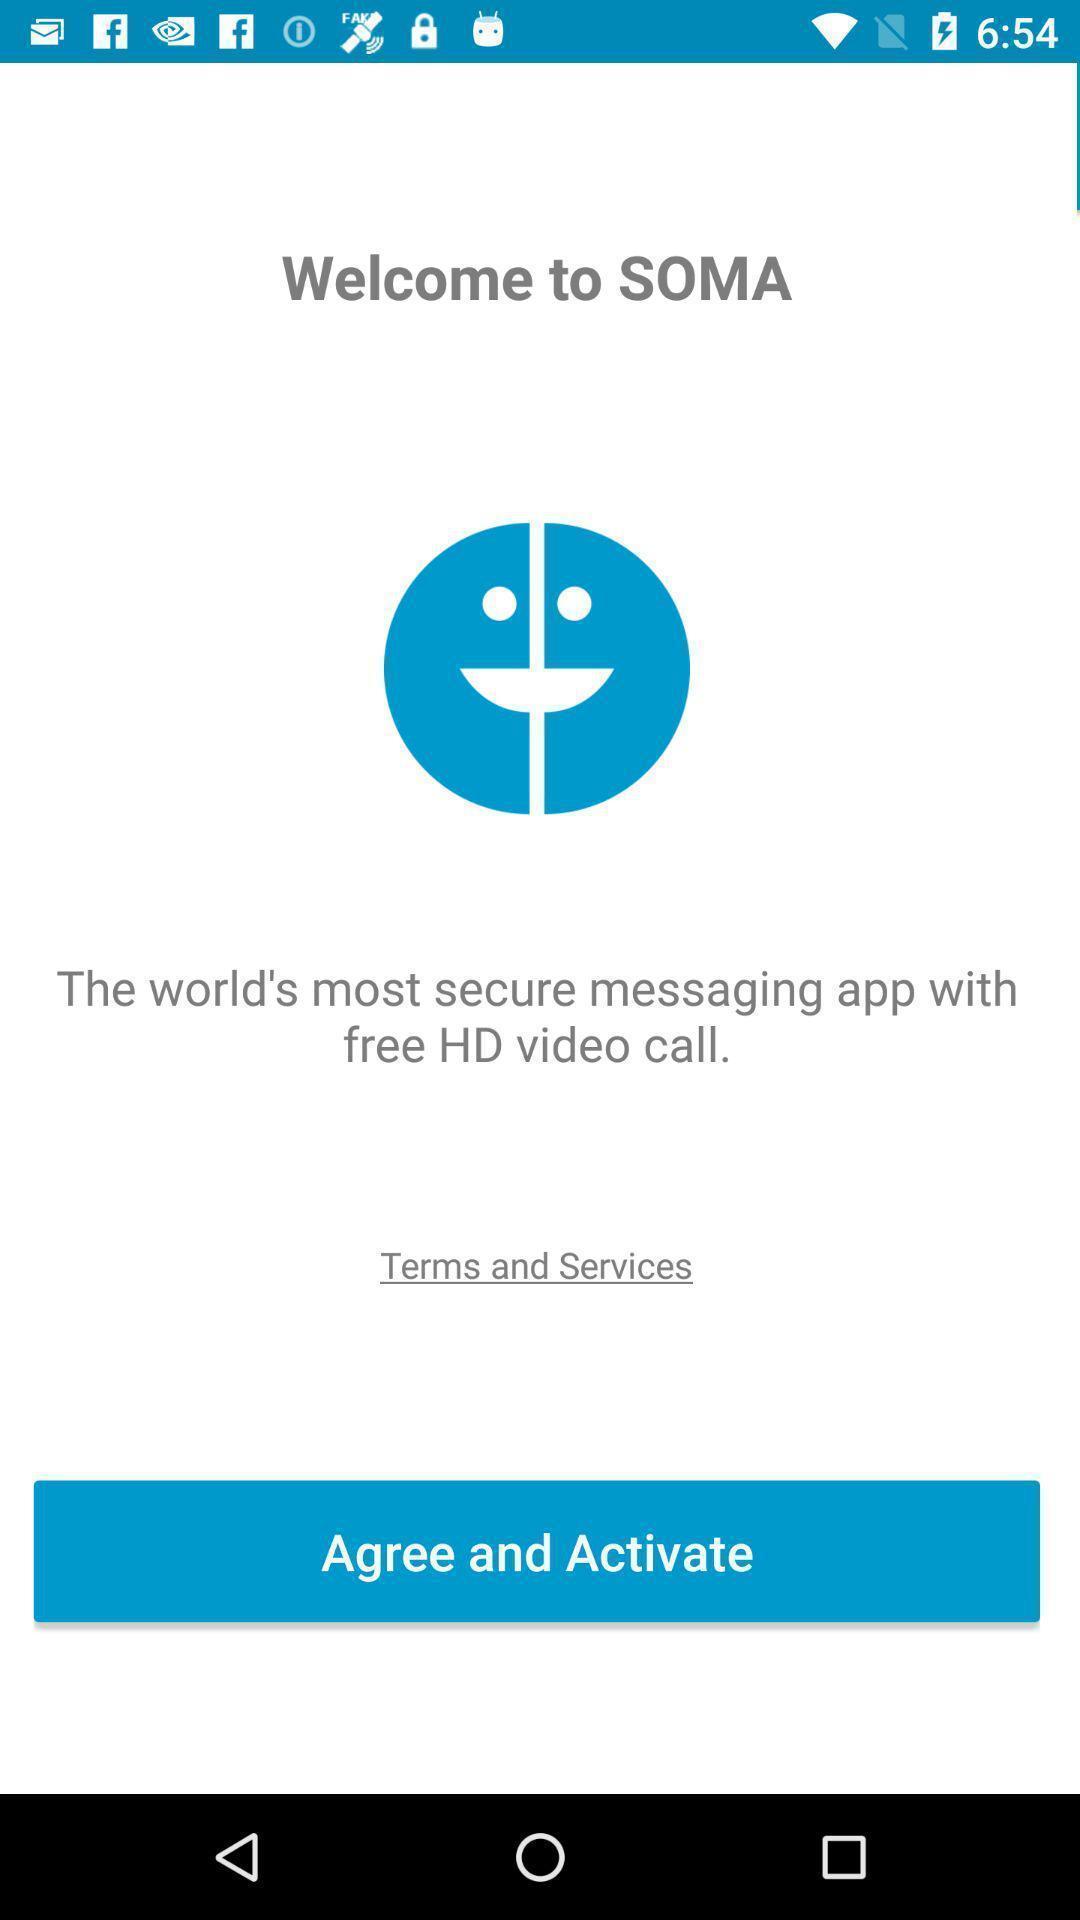Please provide a description for this image. Welcome page. 